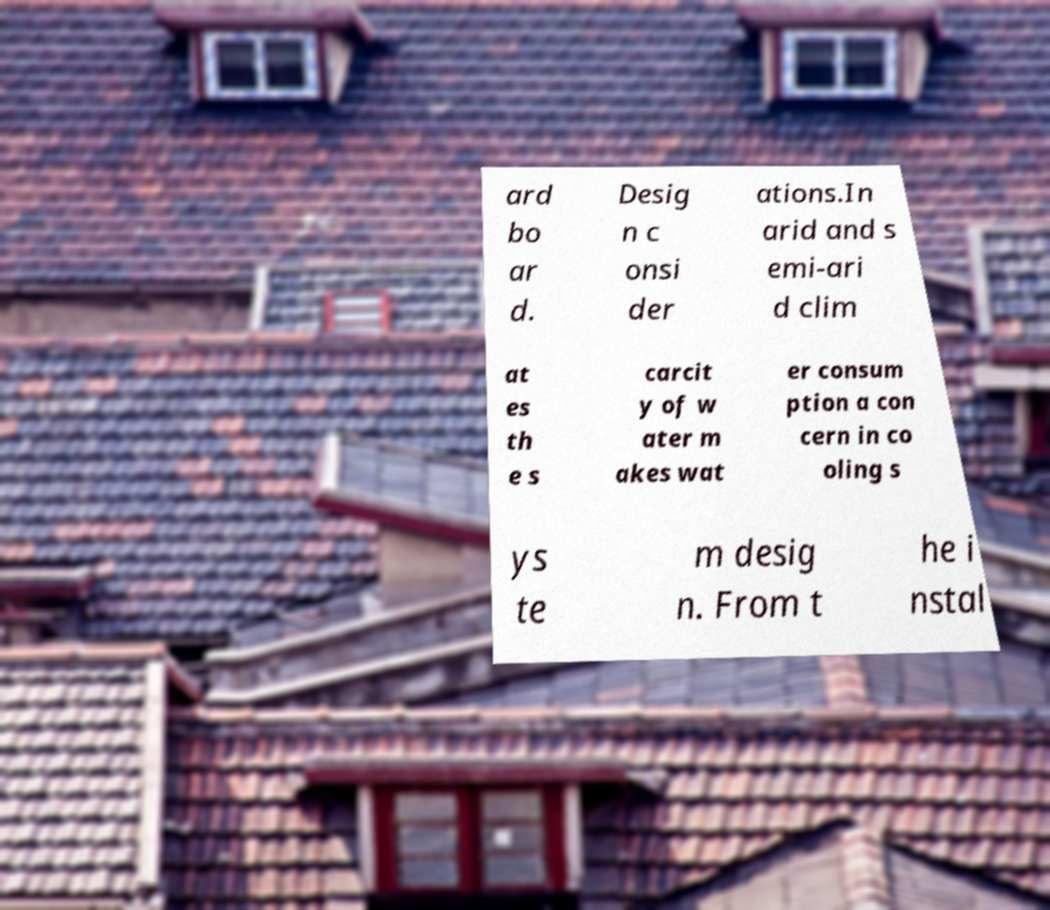Can you read and provide the text displayed in the image?This photo seems to have some interesting text. Can you extract and type it out for me? ard bo ar d. Desig n c onsi der ations.In arid and s emi-ari d clim at es th e s carcit y of w ater m akes wat er consum ption a con cern in co oling s ys te m desig n. From t he i nstal 